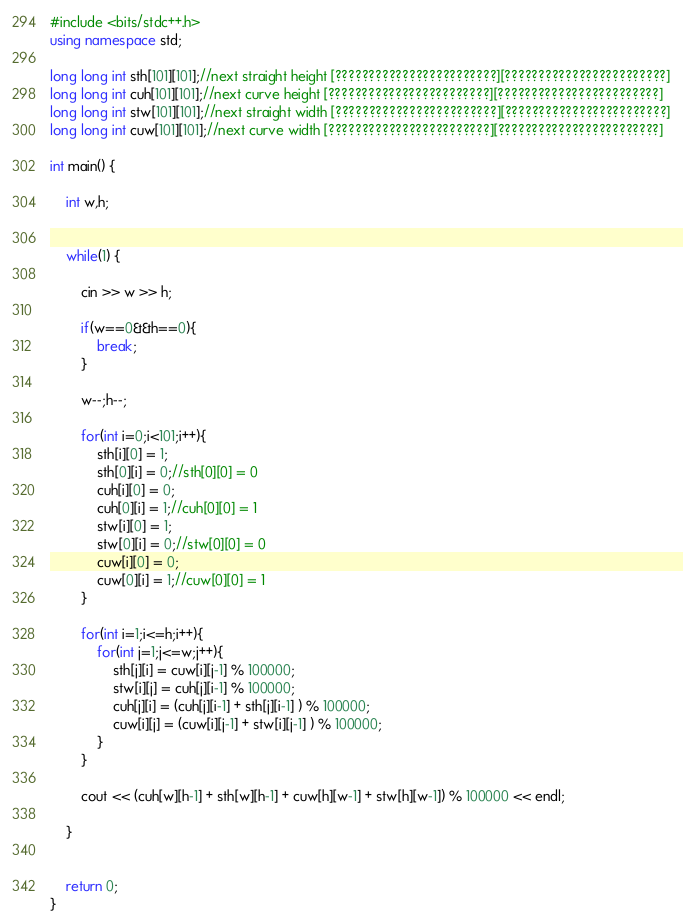Convert code to text. <code><loc_0><loc_0><loc_500><loc_500><_C++_>#include <bits/stdc++.h>
using namespace std;

long long int sth[101][101];//next straight height [????????????????????????][????????????????????????]
long long int cuh[101][101];//next curve height [????????????????????????][????????????????????????]
long long int stw[101][101];//next straight width [????????????????????????][????????????????????????]
long long int cuw[101][101];//next curve width [????????????????????????][????????????????????????]

int main() {

    int w,h;


    while(1) {

        cin >> w >> h;

        if(w==0&&h==0){
            break;
        }

        w--;h--;

        for(int i=0;i<101;i++){
            sth[i][0] = 1;
            sth[0][i] = 0;//sth[0][0] = 0
            cuh[i][0] = 0;
            cuh[0][i] = 1;//cuh[0][0] = 1
            stw[i][0] = 1;
            stw[0][i] = 0;//stw[0][0] = 0
            cuw[i][0] = 0;
            cuw[0][i] = 1;//cuw[0][0] = 1
        }

        for(int i=1;i<=h;i++){
            for(int j=1;j<=w;j++){
                sth[j][i] = cuw[i][j-1] % 100000;
                stw[i][j] = cuh[j][i-1] % 100000;
                cuh[j][i] = (cuh[j][i-1] + sth[j][i-1] ) % 100000;
                cuw[i][j] = (cuw[i][j-1] + stw[i][j-1] ) % 100000;
            }
        }
 
        cout << (cuh[w][h-1] + sth[w][h-1] + cuw[h][w-1] + stw[h][w-1]) % 100000 << endl;

    }


    return 0;
}</code> 